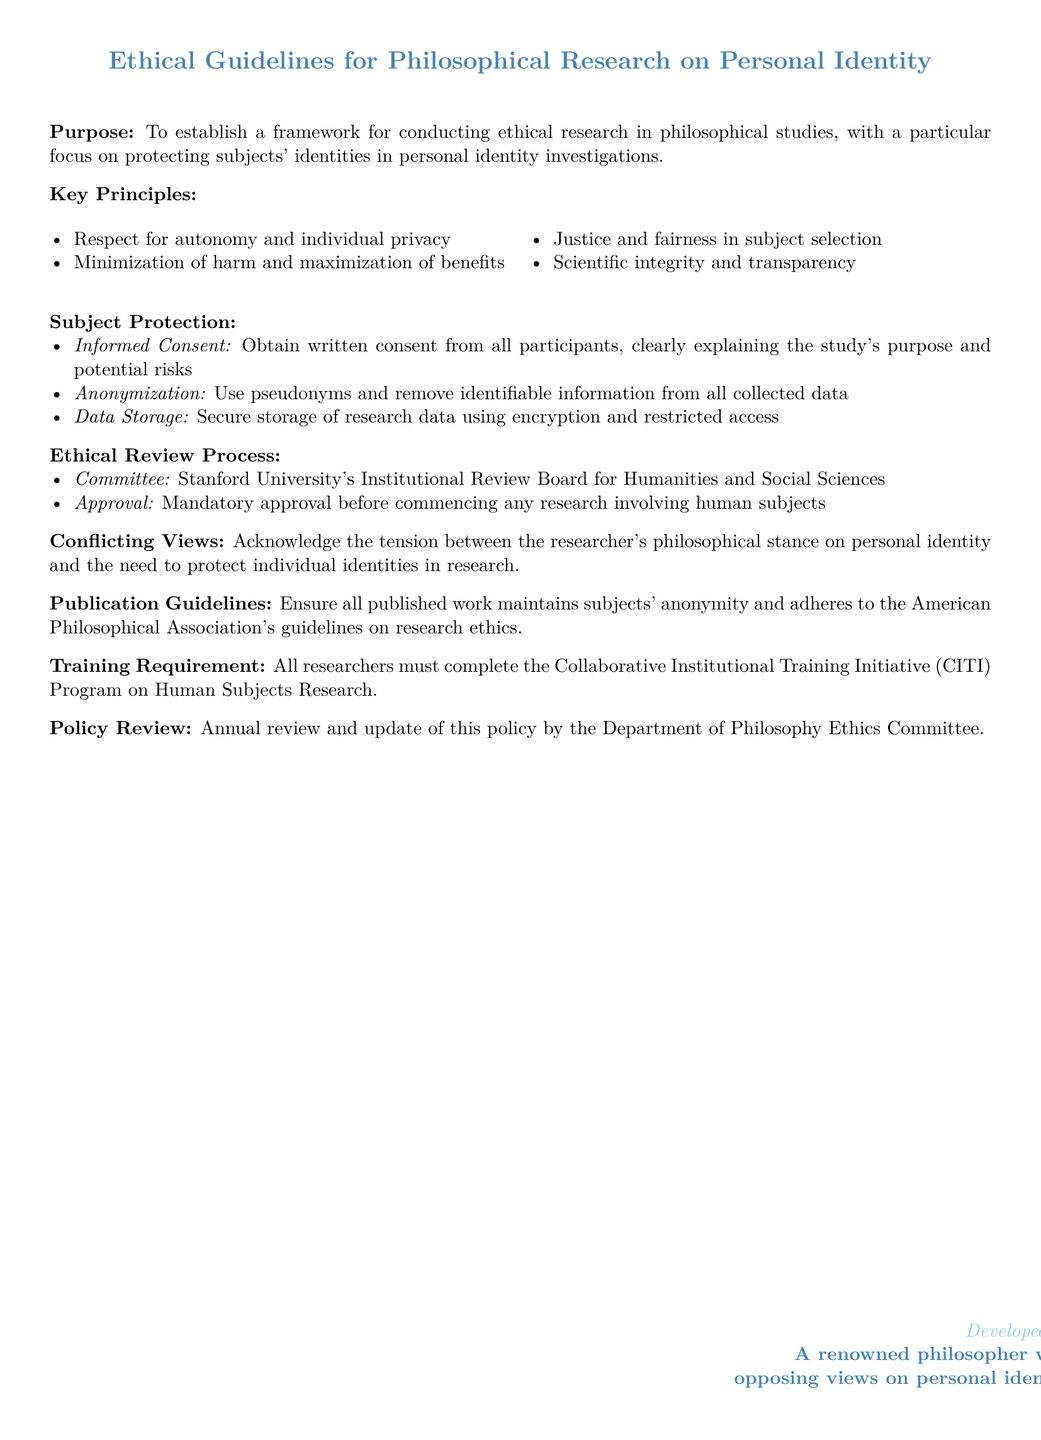What is the purpose of the document? The purpose is to establish a framework for conducting ethical research in philosophical studies, with a focus on protecting subjects' identities.
Answer: establishing a framework for conducting ethical research What are the key principles outlined? The key principles include respect for autonomy, minimization of harm, justice in selection, and scientific integrity.
Answer: respect for autonomy and individual privacy, minimization of harm and maximization of benefits, justice and fairness in subject selection, scientific integrity and transparency Who must approve the research before it begins? The required approval is from the Institutional Review Board for Humanities and Social Sciences at Stanford University.
Answer: Stanford University's Institutional Review Board for Humanities and Social Sciences What training must all researchers complete? Researchers must complete the Collaborative Institutional Training Initiative Program on Human Subjects Research.
Answer: Collaborative Institutional Training Initiative (CITI) Program How often will the policy be reviewed? The policy will be reviewed annually by the Department of Philosophy Ethics Committee.
Answer: Annual review What is the focus of the conflicting views section? The focus is on the tension between philosophical stance on personal identity and the need to protect individual identities.
Answer: tension between the researcher's philosophical stance on personal identity and the need to protect individual identities What method is recommended for data storage? The recommended method for data storage is secure storage using encryption and restricted access.
Answer: secure storage of research data using encryption and restricted access What is required from participants regarding consent? Participants must provide written consent, clearly explaining the study's purpose and potential risks.
Answer: Obtain written consent from all participants 